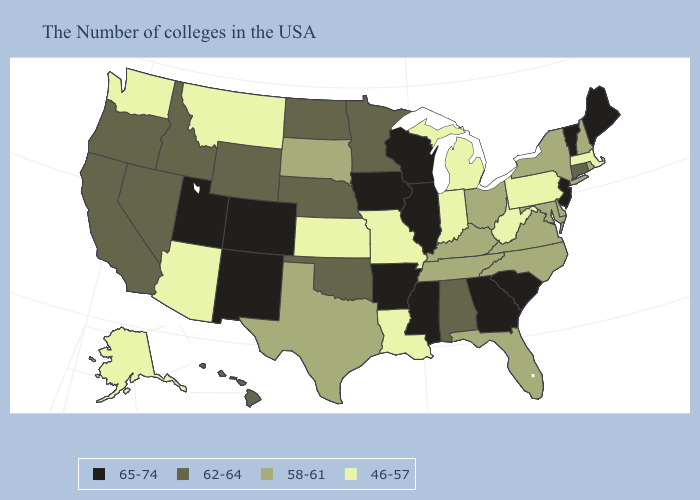Name the states that have a value in the range 46-57?
Give a very brief answer. Massachusetts, Pennsylvania, West Virginia, Michigan, Indiana, Louisiana, Missouri, Kansas, Montana, Arizona, Washington, Alaska. What is the value of Minnesota?
Concise answer only. 62-64. Does California have the highest value in the West?
Short answer required. No. Among the states that border New Jersey , which have the highest value?
Short answer required. New York, Delaware. Does the map have missing data?
Give a very brief answer. No. Does the map have missing data?
Write a very short answer. No. Does Utah have a higher value than Georgia?
Answer briefly. No. Does Massachusetts have the lowest value in the USA?
Short answer required. Yes. What is the value of Louisiana?
Concise answer only. 46-57. Which states hav the highest value in the South?
Quick response, please. South Carolina, Georgia, Mississippi, Arkansas. What is the lowest value in the USA?
Be succinct. 46-57. Does Pennsylvania have the lowest value in the Northeast?
Write a very short answer. Yes. Among the states that border Pennsylvania , which have the lowest value?
Quick response, please. West Virginia. Does Hawaii have the lowest value in the West?
Give a very brief answer. No. Which states hav the highest value in the West?
Give a very brief answer. Colorado, New Mexico, Utah. 